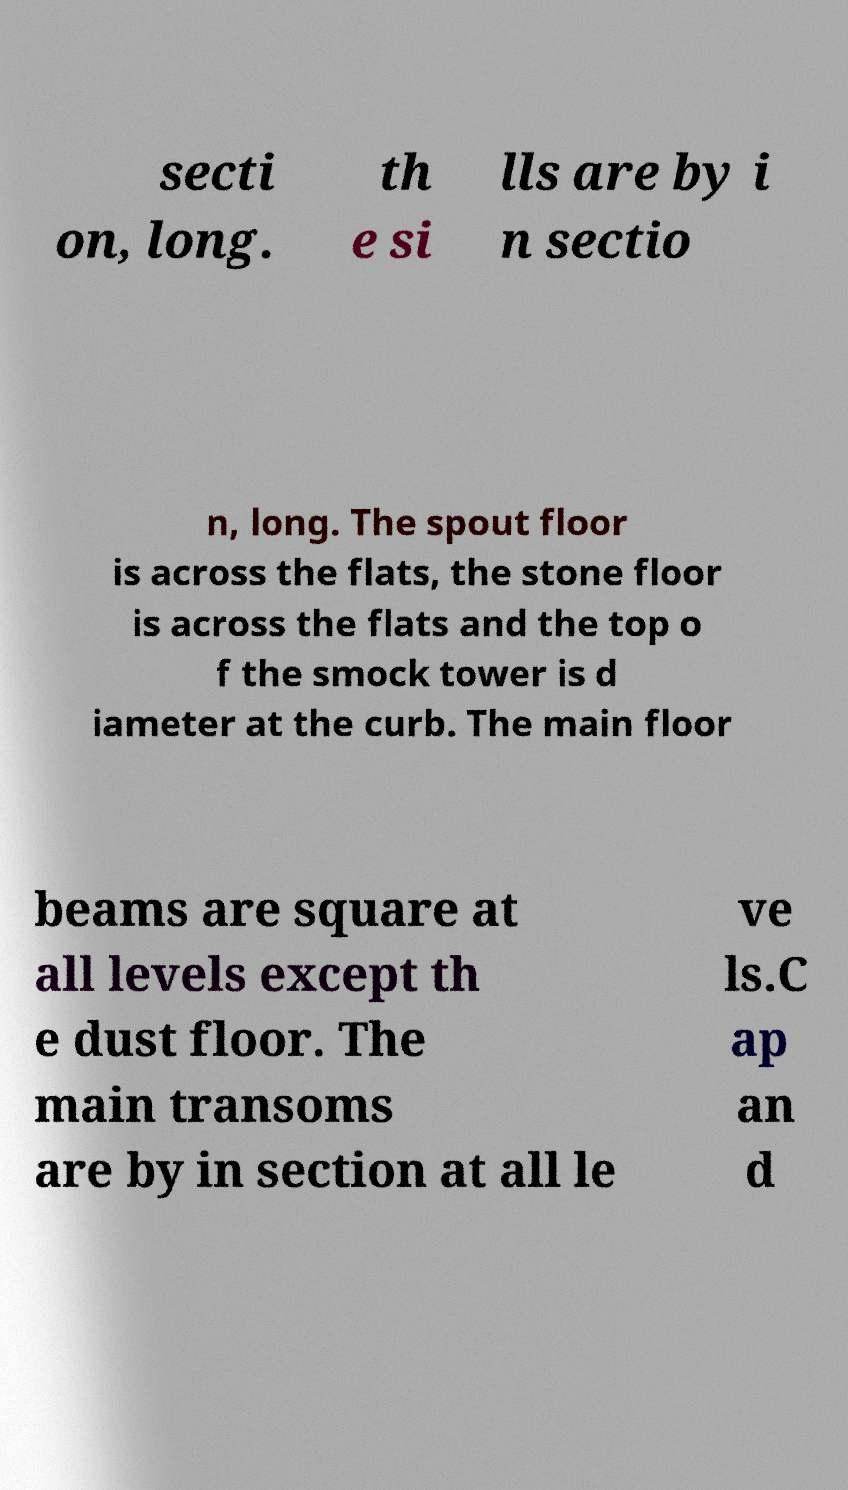I need the written content from this picture converted into text. Can you do that? secti on, long. th e si lls are by i n sectio n, long. The spout floor is across the flats, the stone floor is across the flats and the top o f the smock tower is d iameter at the curb. The main floor beams are square at all levels except th e dust floor. The main transoms are by in section at all le ve ls.C ap an d 